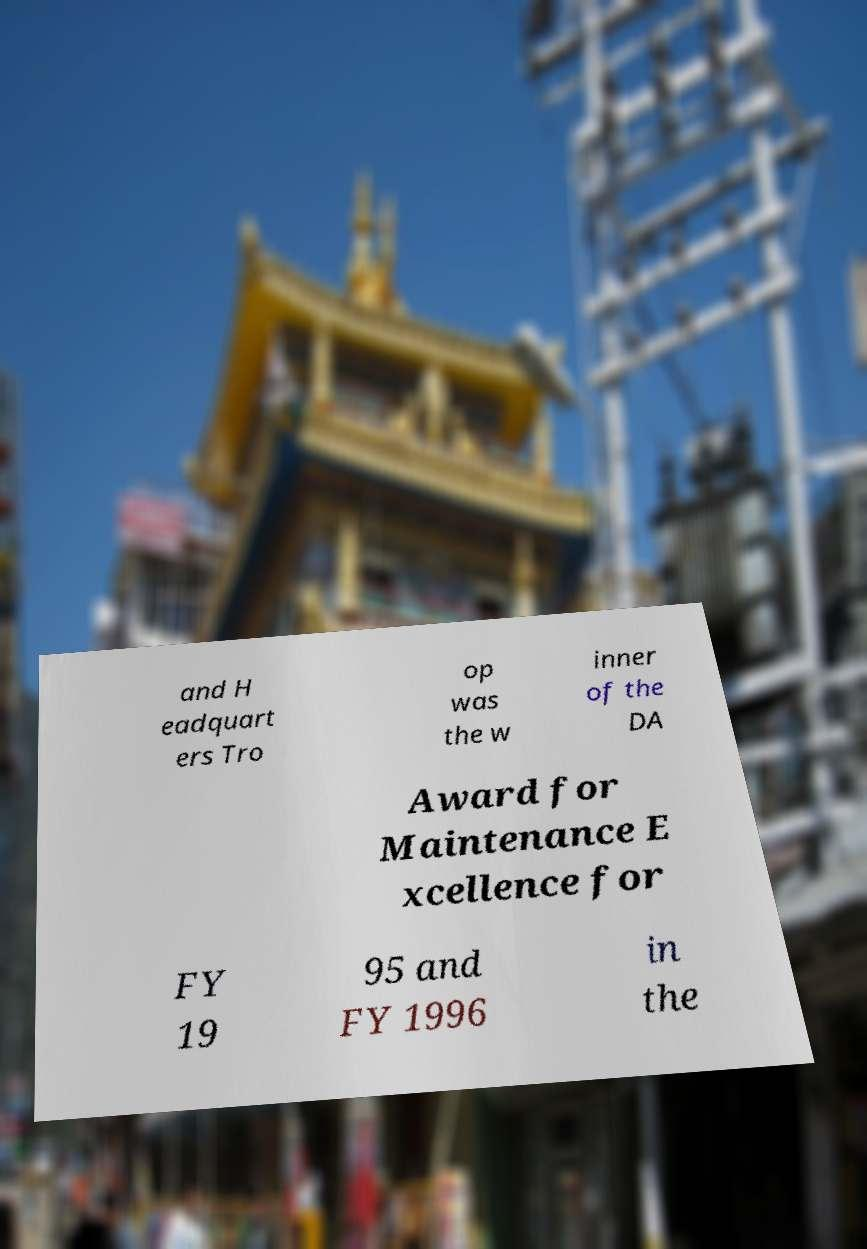For documentation purposes, I need the text within this image transcribed. Could you provide that? and H eadquart ers Tro op was the w inner of the DA Award for Maintenance E xcellence for FY 19 95 and FY 1996 in the 